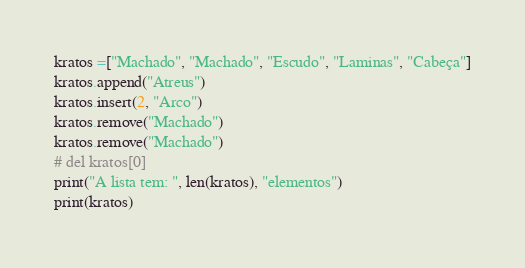Convert code to text. <code><loc_0><loc_0><loc_500><loc_500><_Python_>kratos =["Machado", "Machado", "Escudo", "Laminas", "Cabeça"]
kratos.append("Atreus")
kratos.insert(2, "Arco")
kratos.remove("Machado")
kratos.remove("Machado")
# del kratos[0]
print("A lista tem: ", len(kratos), "elementos")
print(kratos)
</code> 